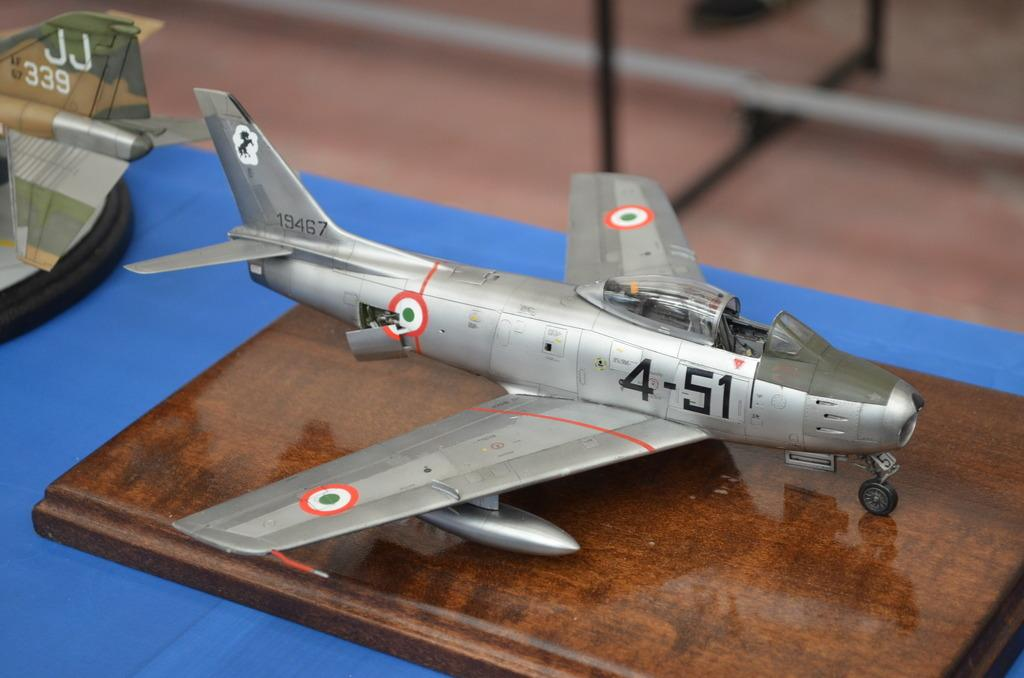What type of toys are present in the image? There are toy aeroplanes in the image. How are the toy aeroplanes arranged in the image? The toy aeroplanes are placed on a surface. What is the mindset of the toy aeroplanes in the image? The toy aeroplanes do not have a mindset, as they are inanimate objects. 